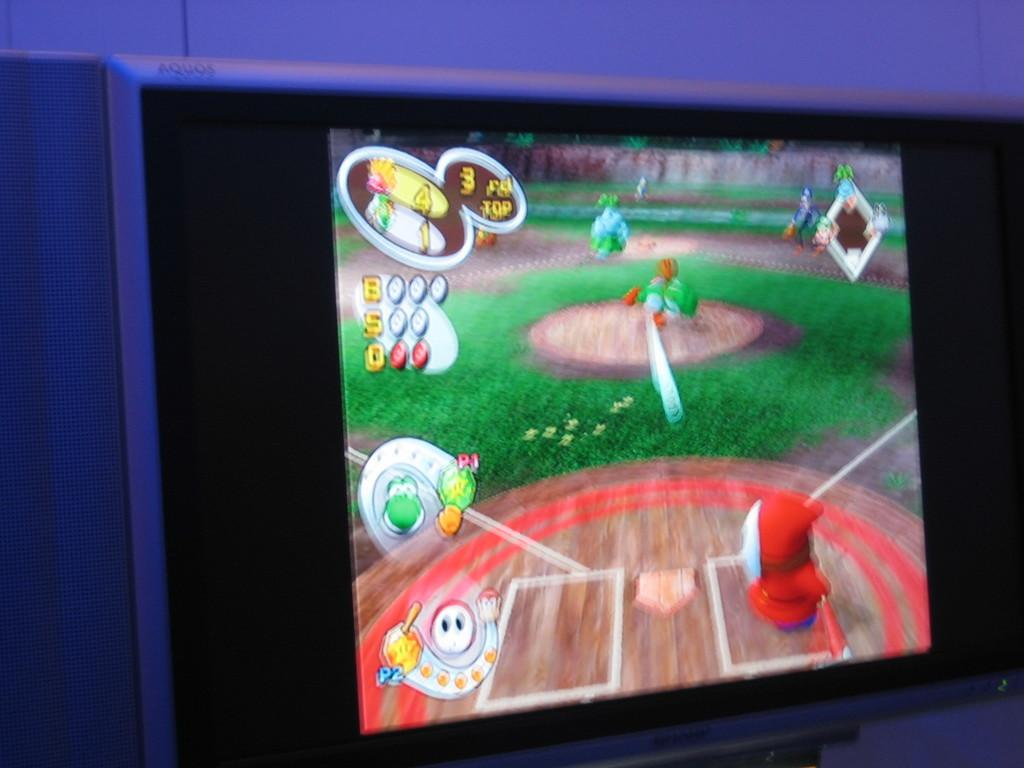<image>
Render a clear and concise summary of the photo. a screen that has the numbers 4 and 3 on it 